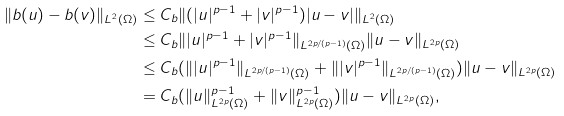Convert formula to latex. <formula><loc_0><loc_0><loc_500><loc_500>\| b ( u ) - b ( v ) \| _ { L ^ { 2 } ( \Omega ) } & \leq C _ { b } \| ( | u | ^ { p - 1 } + | v | ^ { p - 1 } ) | u - v | \| _ { L ^ { 2 } ( \Omega ) } \\ & \leq C _ { b } \| | u | ^ { p - 1 } + | v | ^ { p - 1 } \| _ { L ^ { 2 p / ( p - 1 ) } ( \Omega ) } \| u - v \| _ { L ^ { 2 p } ( \Omega ) } \\ & \leq C _ { b } ( \| | u | ^ { p - 1 } \| _ { L ^ { 2 p / ( p - 1 ) } ( \Omega ) } + \| | v | ^ { p - 1 } \| _ { L ^ { 2 p / ( p - 1 ) } ( \Omega ) } ) \| u - v \| _ { L ^ { 2 p } ( \Omega ) } \\ & = C _ { b } ( \| u \| ^ { p - 1 } _ { L ^ { 2 p } ( \Omega ) } + \| v \| ^ { p - 1 } _ { L ^ { 2 p } ( \Omega ) } ) \| u - v \| _ { L ^ { 2 p } ( \Omega ) } ,</formula> 